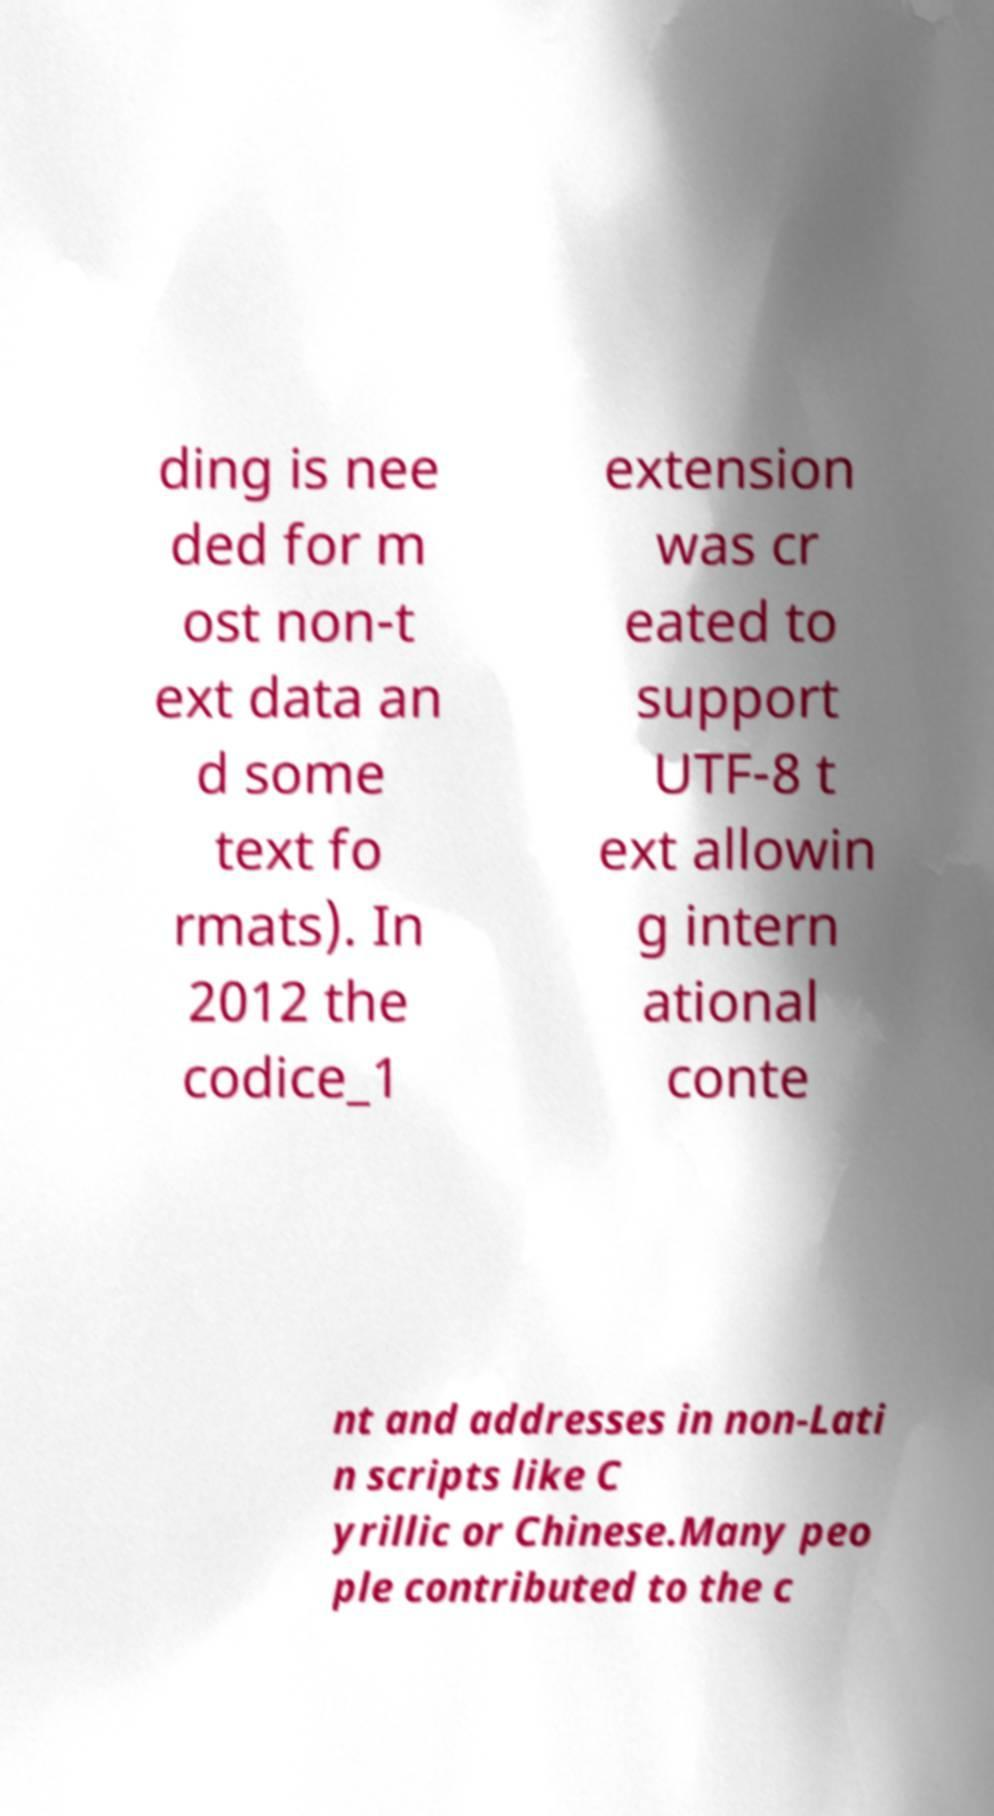Can you read and provide the text displayed in the image?This photo seems to have some interesting text. Can you extract and type it out for me? ding is nee ded for m ost non-t ext data an d some text fo rmats). In 2012 the codice_1 extension was cr eated to support UTF-8 t ext allowin g intern ational conte nt and addresses in non-Lati n scripts like C yrillic or Chinese.Many peo ple contributed to the c 